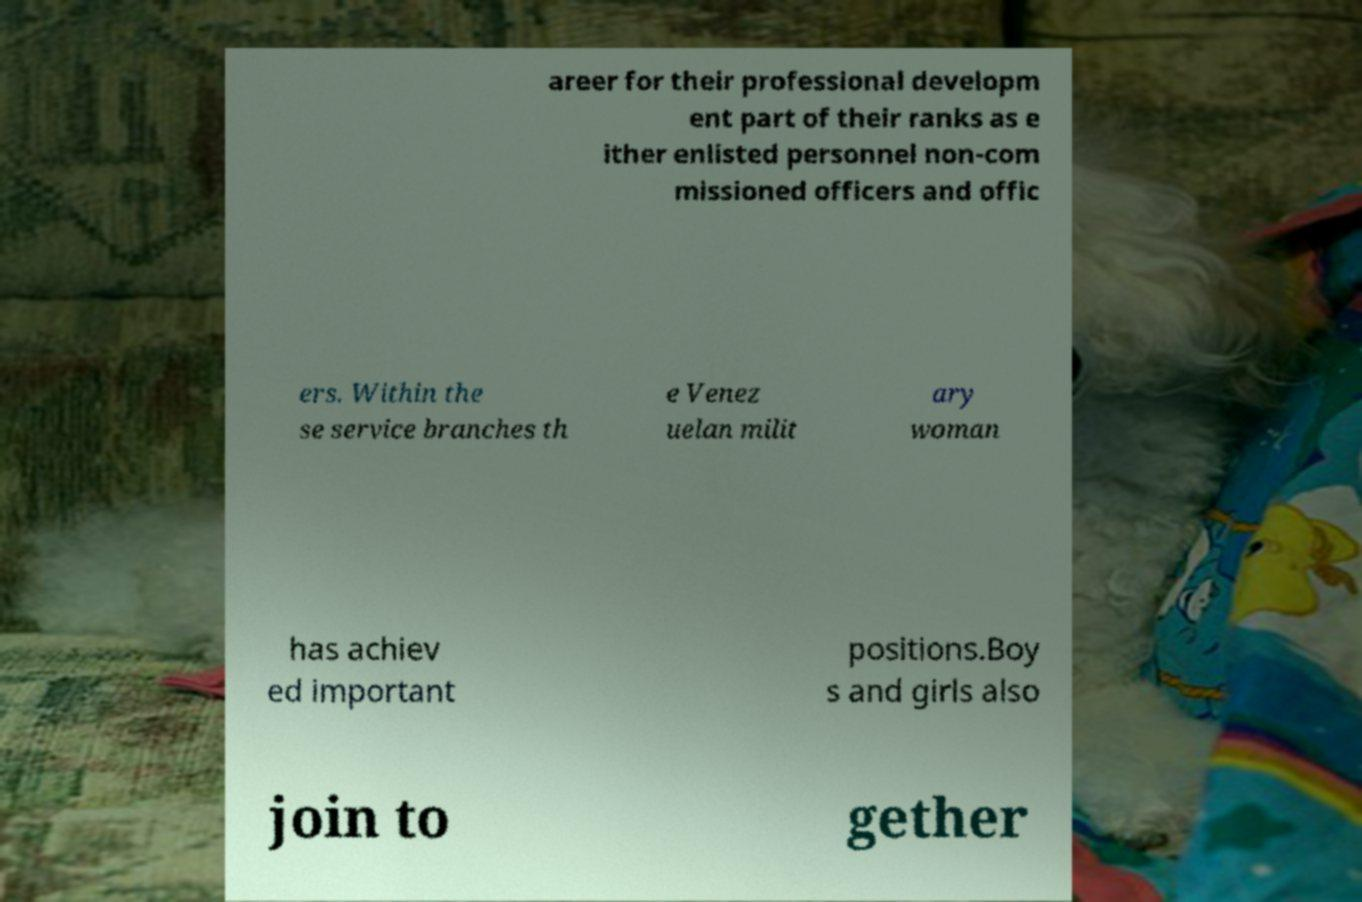Could you assist in decoding the text presented in this image and type it out clearly? areer for their professional developm ent part of their ranks as e ither enlisted personnel non-com missioned officers and offic ers. Within the se service branches th e Venez uelan milit ary woman has achiev ed important positions.Boy s and girls also join to gether 